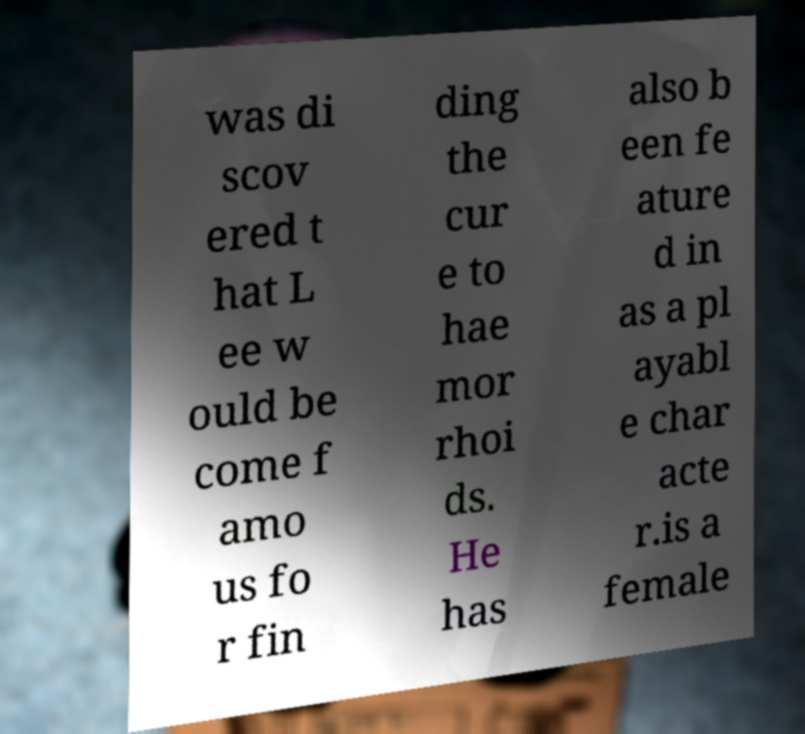For documentation purposes, I need the text within this image transcribed. Could you provide that? was di scov ered t hat L ee w ould be come f amo us fo r fin ding the cur e to hae mor rhoi ds. He has also b een fe ature d in as a pl ayabl e char acte r.is a female 